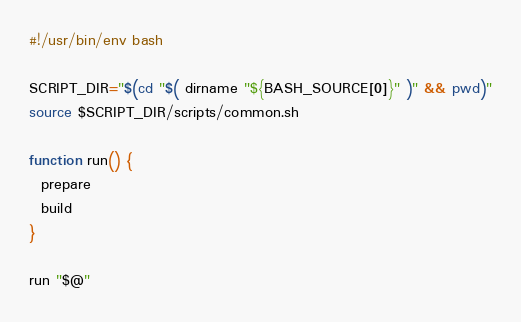Convert code to text. <code><loc_0><loc_0><loc_500><loc_500><_Bash_>#!/usr/bin/env bash

SCRIPT_DIR="$(cd "$( dirname "${BASH_SOURCE[0]}" )" && pwd)"
source $SCRIPT_DIR/scripts/common.sh

function run() {
  prepare
  build
}

run "$@"
</code> 